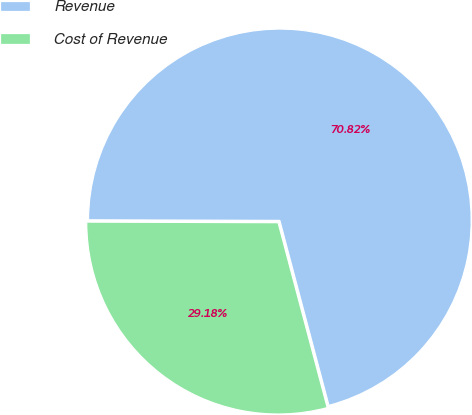Convert chart to OTSL. <chart><loc_0><loc_0><loc_500><loc_500><pie_chart><fcel>Revenue<fcel>Cost of Revenue<nl><fcel>70.82%<fcel>29.18%<nl></chart> 